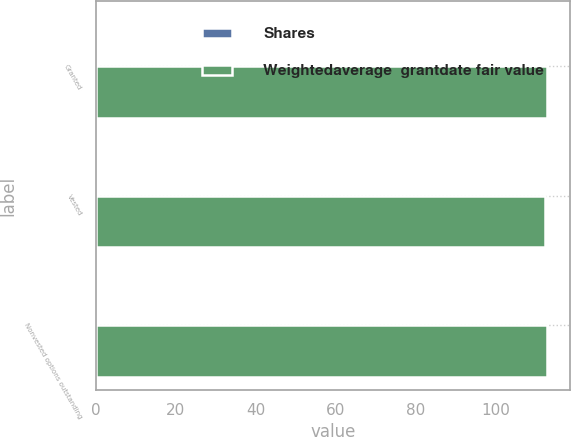Convert chart. <chart><loc_0><loc_0><loc_500><loc_500><stacked_bar_chart><ecel><fcel>Granted<fcel>Vested<fcel>Nonvested options outstanding<nl><fcel>Shares<fcel>0.2<fcel>0.1<fcel>0.1<nl><fcel>Weightedaverage  grantdate fair value<fcel>112.98<fcel>112.36<fcel>113.02<nl></chart> 